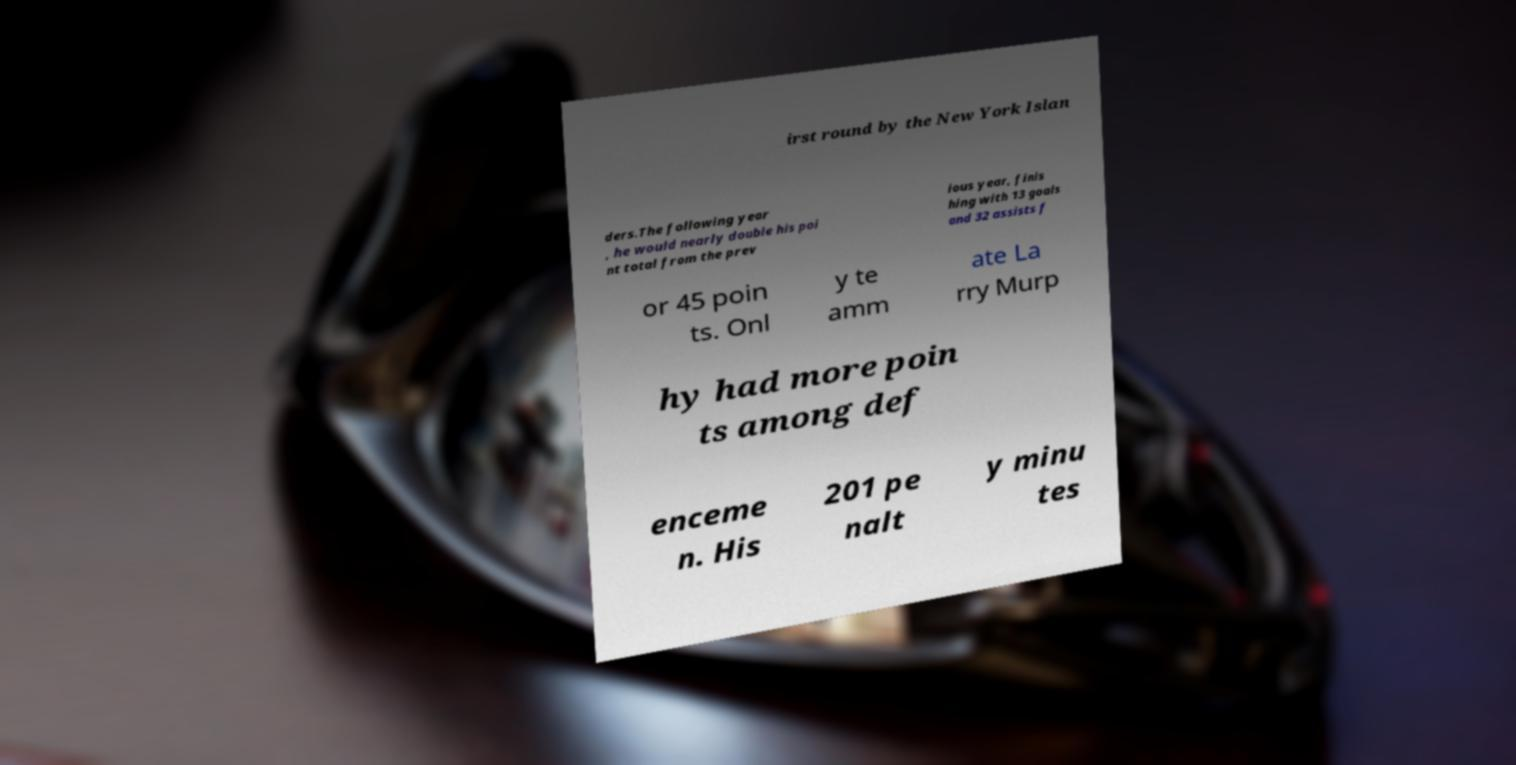Can you accurately transcribe the text from the provided image for me? irst round by the New York Islan ders.The following year , he would nearly double his poi nt total from the prev ious year, finis hing with 13 goals and 32 assists f or 45 poin ts. Onl y te amm ate La rry Murp hy had more poin ts among def enceme n. His 201 pe nalt y minu tes 